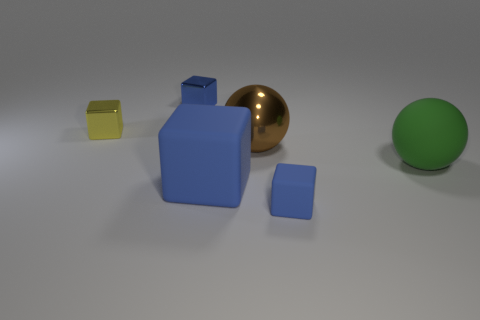Add 3 small gray rubber cylinders. How many objects exist? 9 Subtract all small blue rubber blocks. How many blocks are left? 3 Subtract 2 balls. How many balls are left? 0 Subtract all blue cubes. How many cubes are left? 1 Subtract all balls. How many objects are left? 4 Subtract all green cylinders. How many blue blocks are left? 3 Subtract all big shiny objects. Subtract all big matte things. How many objects are left? 3 Add 4 yellow things. How many yellow things are left? 5 Add 2 purple metallic balls. How many purple metallic balls exist? 2 Subtract 0 red cylinders. How many objects are left? 6 